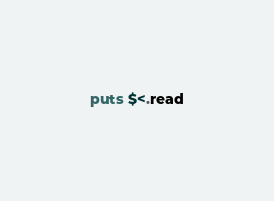Convert code to text. <code><loc_0><loc_0><loc_500><loc_500><_Ruby_>puts $<.read</code> 